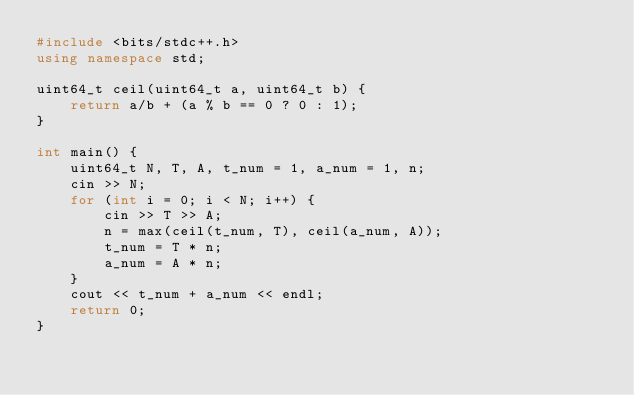Convert code to text. <code><loc_0><loc_0><loc_500><loc_500><_C++_>#include <bits/stdc++.h>
using namespace std;

uint64_t ceil(uint64_t a, uint64_t b) {
    return a/b + (a % b == 0 ? 0 : 1);
}

int main() {
    uint64_t N, T, A, t_num = 1, a_num = 1, n;
    cin >> N;
    for (int i = 0; i < N; i++) {
        cin >> T >> A;
        n = max(ceil(t_num, T), ceil(a_num, A));
        t_num = T * n;
        a_num = A * n;
    }
    cout << t_num + a_num << endl;
    return 0;
}
</code> 